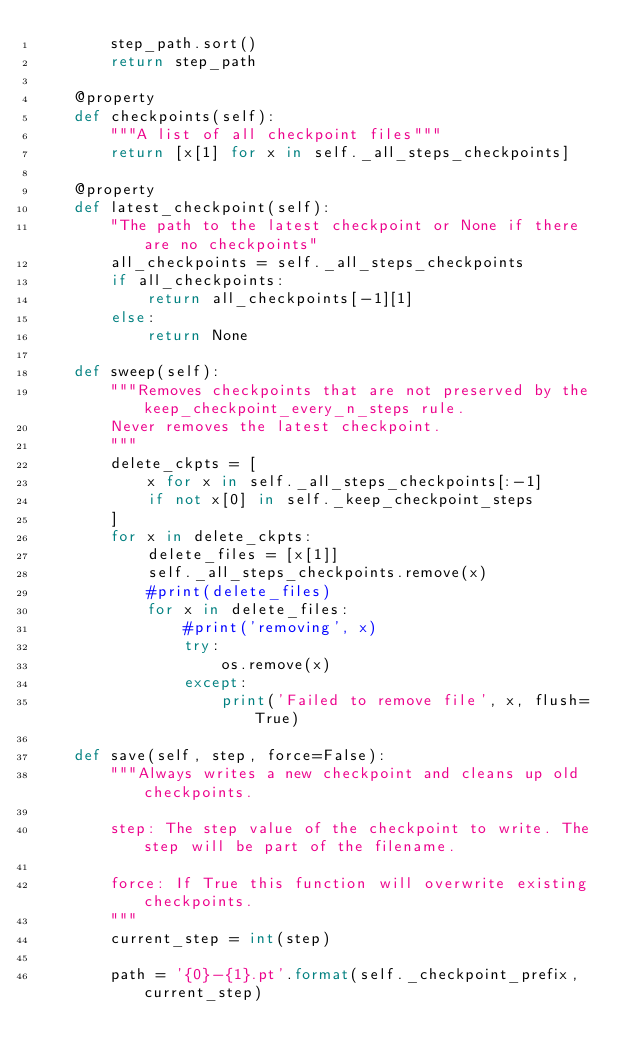Convert code to text. <code><loc_0><loc_0><loc_500><loc_500><_Python_>        step_path.sort()
        return step_path

    @property
    def checkpoints(self):
        """A list of all checkpoint files"""
        return [x[1] for x in self._all_steps_checkpoints]

    @property
    def latest_checkpoint(self):
        "The path to the latest checkpoint or None if there are no checkpoints"
        all_checkpoints = self._all_steps_checkpoints
        if all_checkpoints:
            return all_checkpoints[-1][1]
        else:
            return None

    def sweep(self):
        """Removes checkpoints that are not preserved by the keep_checkpoint_every_n_steps rule.
        Never removes the latest checkpoint.
        """
        delete_ckpts = [
            x for x in self._all_steps_checkpoints[:-1]
            if not x[0] in self._keep_checkpoint_steps
        ]
        for x in delete_ckpts:
            delete_files = [x[1]]
            self._all_steps_checkpoints.remove(x)
            #print(delete_files)
            for x in delete_files:
                #print('removing', x)
                try:
                    os.remove(x)
                except:
                    print('Failed to remove file', x, flush=True)

    def save(self, step, force=False):
        """Always writes a new checkpoint and cleans up old checkpoints.

        step: The step value of the checkpoint to write. The step will be part of the filename.

        force: If True this function will overwrite existing checkpoints.
        """
        current_step = int(step)

        path = '{0}-{1}.pt'.format(self._checkpoint_prefix, current_step)</code> 